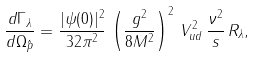<formula> <loc_0><loc_0><loc_500><loc_500>\frac { d \Gamma _ { \lambda } } { d \Omega _ { \hat { p } } } = \frac { | \psi ( 0 ) | ^ { 2 } } { 3 2 \pi ^ { 2 } } \, \left ( \frac { g ^ { 2 } } { 8 M ^ { 2 } } \right ) ^ { 2 } \, V ^ { 2 } _ { u d } \, \frac { \nu ^ { 2 } } { s } \, R _ { \lambda } ,</formula> 